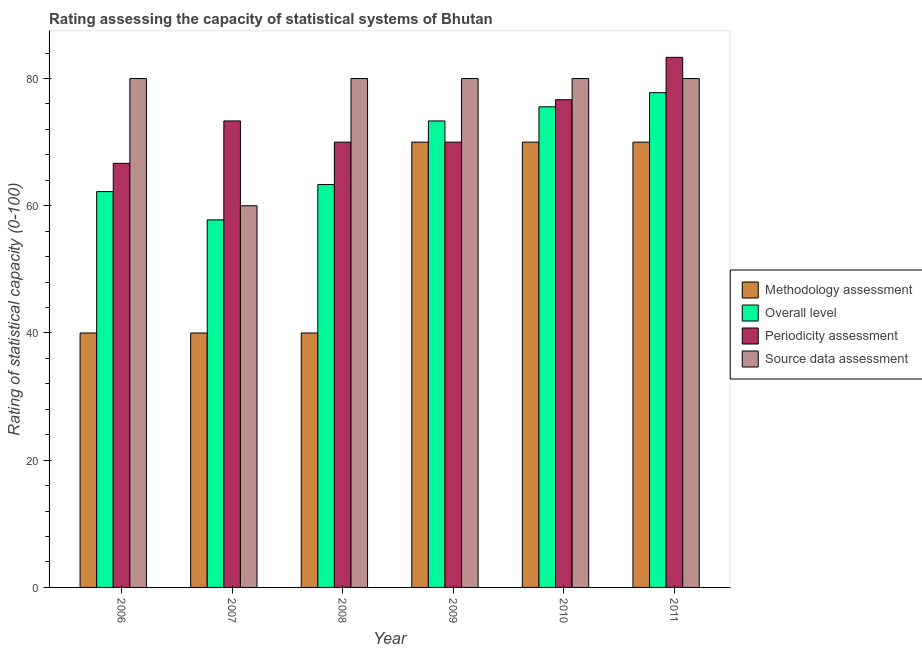How many different coloured bars are there?
Provide a short and direct response. 4. Are the number of bars per tick equal to the number of legend labels?
Provide a short and direct response. Yes. How many bars are there on the 5th tick from the left?
Provide a short and direct response. 4. What is the label of the 6th group of bars from the left?
Give a very brief answer. 2011. What is the methodology assessment rating in 2010?
Your answer should be very brief. 70. Across all years, what is the maximum source data assessment rating?
Your answer should be compact. 80. Across all years, what is the minimum periodicity assessment rating?
Offer a terse response. 66.67. In which year was the source data assessment rating maximum?
Give a very brief answer. 2006. What is the total methodology assessment rating in the graph?
Your answer should be compact. 330. What is the difference between the periodicity assessment rating in 2007 and that in 2008?
Keep it short and to the point. 3.33. What is the average periodicity assessment rating per year?
Make the answer very short. 73.33. What is the ratio of the source data assessment rating in 2006 to that in 2010?
Offer a terse response. 1. What is the difference between the highest and the second highest periodicity assessment rating?
Ensure brevity in your answer.  6.67. What is the difference between the highest and the lowest periodicity assessment rating?
Make the answer very short. 16.67. In how many years, is the overall level rating greater than the average overall level rating taken over all years?
Your response must be concise. 3. Is the sum of the periodicity assessment rating in 2007 and 2010 greater than the maximum overall level rating across all years?
Keep it short and to the point. Yes. What does the 3rd bar from the left in 2008 represents?
Offer a very short reply. Periodicity assessment. What does the 1st bar from the right in 2011 represents?
Provide a short and direct response. Source data assessment. How many bars are there?
Provide a succinct answer. 24. Are the values on the major ticks of Y-axis written in scientific E-notation?
Give a very brief answer. No. Does the graph contain any zero values?
Provide a short and direct response. No. Does the graph contain grids?
Your answer should be compact. No. Where does the legend appear in the graph?
Make the answer very short. Center right. How many legend labels are there?
Your answer should be very brief. 4. What is the title of the graph?
Your answer should be compact. Rating assessing the capacity of statistical systems of Bhutan. What is the label or title of the X-axis?
Your answer should be compact. Year. What is the label or title of the Y-axis?
Your response must be concise. Rating of statistical capacity (0-100). What is the Rating of statistical capacity (0-100) of Methodology assessment in 2006?
Your answer should be very brief. 40. What is the Rating of statistical capacity (0-100) in Overall level in 2006?
Offer a very short reply. 62.22. What is the Rating of statistical capacity (0-100) of Periodicity assessment in 2006?
Keep it short and to the point. 66.67. What is the Rating of statistical capacity (0-100) of Methodology assessment in 2007?
Provide a short and direct response. 40. What is the Rating of statistical capacity (0-100) in Overall level in 2007?
Offer a very short reply. 57.78. What is the Rating of statistical capacity (0-100) in Periodicity assessment in 2007?
Your response must be concise. 73.33. What is the Rating of statistical capacity (0-100) in Overall level in 2008?
Keep it short and to the point. 63.33. What is the Rating of statistical capacity (0-100) of Periodicity assessment in 2008?
Provide a short and direct response. 70. What is the Rating of statistical capacity (0-100) of Source data assessment in 2008?
Your answer should be very brief. 80. What is the Rating of statistical capacity (0-100) of Methodology assessment in 2009?
Make the answer very short. 70. What is the Rating of statistical capacity (0-100) in Overall level in 2009?
Your response must be concise. 73.33. What is the Rating of statistical capacity (0-100) in Periodicity assessment in 2009?
Make the answer very short. 70. What is the Rating of statistical capacity (0-100) in Methodology assessment in 2010?
Keep it short and to the point. 70. What is the Rating of statistical capacity (0-100) in Overall level in 2010?
Your answer should be compact. 75.56. What is the Rating of statistical capacity (0-100) in Periodicity assessment in 2010?
Keep it short and to the point. 76.67. What is the Rating of statistical capacity (0-100) in Overall level in 2011?
Make the answer very short. 77.78. What is the Rating of statistical capacity (0-100) of Periodicity assessment in 2011?
Your response must be concise. 83.33. What is the Rating of statistical capacity (0-100) in Source data assessment in 2011?
Your answer should be compact. 80. Across all years, what is the maximum Rating of statistical capacity (0-100) of Overall level?
Make the answer very short. 77.78. Across all years, what is the maximum Rating of statistical capacity (0-100) of Periodicity assessment?
Your answer should be compact. 83.33. Across all years, what is the maximum Rating of statistical capacity (0-100) of Source data assessment?
Keep it short and to the point. 80. Across all years, what is the minimum Rating of statistical capacity (0-100) in Overall level?
Your answer should be compact. 57.78. Across all years, what is the minimum Rating of statistical capacity (0-100) in Periodicity assessment?
Provide a succinct answer. 66.67. Across all years, what is the minimum Rating of statistical capacity (0-100) in Source data assessment?
Ensure brevity in your answer.  60. What is the total Rating of statistical capacity (0-100) in Methodology assessment in the graph?
Offer a terse response. 330. What is the total Rating of statistical capacity (0-100) in Overall level in the graph?
Offer a terse response. 410. What is the total Rating of statistical capacity (0-100) of Periodicity assessment in the graph?
Your answer should be very brief. 440. What is the total Rating of statistical capacity (0-100) in Source data assessment in the graph?
Provide a succinct answer. 460. What is the difference between the Rating of statistical capacity (0-100) of Overall level in 2006 and that in 2007?
Offer a terse response. 4.44. What is the difference between the Rating of statistical capacity (0-100) of Periodicity assessment in 2006 and that in 2007?
Offer a terse response. -6.67. What is the difference between the Rating of statistical capacity (0-100) of Source data assessment in 2006 and that in 2007?
Your response must be concise. 20. What is the difference between the Rating of statistical capacity (0-100) in Methodology assessment in 2006 and that in 2008?
Your answer should be compact. 0. What is the difference between the Rating of statistical capacity (0-100) in Overall level in 2006 and that in 2008?
Keep it short and to the point. -1.11. What is the difference between the Rating of statistical capacity (0-100) of Periodicity assessment in 2006 and that in 2008?
Offer a terse response. -3.33. What is the difference between the Rating of statistical capacity (0-100) of Overall level in 2006 and that in 2009?
Your answer should be very brief. -11.11. What is the difference between the Rating of statistical capacity (0-100) in Periodicity assessment in 2006 and that in 2009?
Ensure brevity in your answer.  -3.33. What is the difference between the Rating of statistical capacity (0-100) in Methodology assessment in 2006 and that in 2010?
Your answer should be very brief. -30. What is the difference between the Rating of statistical capacity (0-100) in Overall level in 2006 and that in 2010?
Provide a short and direct response. -13.33. What is the difference between the Rating of statistical capacity (0-100) in Periodicity assessment in 2006 and that in 2010?
Offer a terse response. -10. What is the difference between the Rating of statistical capacity (0-100) in Source data assessment in 2006 and that in 2010?
Keep it short and to the point. 0. What is the difference between the Rating of statistical capacity (0-100) in Overall level in 2006 and that in 2011?
Ensure brevity in your answer.  -15.56. What is the difference between the Rating of statistical capacity (0-100) in Periodicity assessment in 2006 and that in 2011?
Ensure brevity in your answer.  -16.67. What is the difference between the Rating of statistical capacity (0-100) of Source data assessment in 2006 and that in 2011?
Keep it short and to the point. 0. What is the difference between the Rating of statistical capacity (0-100) in Overall level in 2007 and that in 2008?
Ensure brevity in your answer.  -5.56. What is the difference between the Rating of statistical capacity (0-100) of Periodicity assessment in 2007 and that in 2008?
Provide a short and direct response. 3.33. What is the difference between the Rating of statistical capacity (0-100) in Source data assessment in 2007 and that in 2008?
Your answer should be compact. -20. What is the difference between the Rating of statistical capacity (0-100) in Methodology assessment in 2007 and that in 2009?
Provide a short and direct response. -30. What is the difference between the Rating of statistical capacity (0-100) in Overall level in 2007 and that in 2009?
Your response must be concise. -15.56. What is the difference between the Rating of statistical capacity (0-100) in Periodicity assessment in 2007 and that in 2009?
Provide a short and direct response. 3.33. What is the difference between the Rating of statistical capacity (0-100) in Source data assessment in 2007 and that in 2009?
Your answer should be compact. -20. What is the difference between the Rating of statistical capacity (0-100) of Overall level in 2007 and that in 2010?
Your answer should be compact. -17.78. What is the difference between the Rating of statistical capacity (0-100) in Source data assessment in 2007 and that in 2010?
Ensure brevity in your answer.  -20. What is the difference between the Rating of statistical capacity (0-100) of Methodology assessment in 2007 and that in 2011?
Your answer should be compact. -30. What is the difference between the Rating of statistical capacity (0-100) of Periodicity assessment in 2007 and that in 2011?
Provide a succinct answer. -10. What is the difference between the Rating of statistical capacity (0-100) of Overall level in 2008 and that in 2009?
Ensure brevity in your answer.  -10. What is the difference between the Rating of statistical capacity (0-100) of Periodicity assessment in 2008 and that in 2009?
Ensure brevity in your answer.  0. What is the difference between the Rating of statistical capacity (0-100) of Methodology assessment in 2008 and that in 2010?
Your answer should be compact. -30. What is the difference between the Rating of statistical capacity (0-100) of Overall level in 2008 and that in 2010?
Your answer should be compact. -12.22. What is the difference between the Rating of statistical capacity (0-100) of Periodicity assessment in 2008 and that in 2010?
Ensure brevity in your answer.  -6.67. What is the difference between the Rating of statistical capacity (0-100) of Source data assessment in 2008 and that in 2010?
Make the answer very short. 0. What is the difference between the Rating of statistical capacity (0-100) in Methodology assessment in 2008 and that in 2011?
Provide a short and direct response. -30. What is the difference between the Rating of statistical capacity (0-100) of Overall level in 2008 and that in 2011?
Offer a terse response. -14.44. What is the difference between the Rating of statistical capacity (0-100) of Periodicity assessment in 2008 and that in 2011?
Your answer should be very brief. -13.33. What is the difference between the Rating of statistical capacity (0-100) in Overall level in 2009 and that in 2010?
Make the answer very short. -2.22. What is the difference between the Rating of statistical capacity (0-100) in Periodicity assessment in 2009 and that in 2010?
Keep it short and to the point. -6.67. What is the difference between the Rating of statistical capacity (0-100) of Source data assessment in 2009 and that in 2010?
Make the answer very short. 0. What is the difference between the Rating of statistical capacity (0-100) of Methodology assessment in 2009 and that in 2011?
Offer a very short reply. 0. What is the difference between the Rating of statistical capacity (0-100) of Overall level in 2009 and that in 2011?
Give a very brief answer. -4.44. What is the difference between the Rating of statistical capacity (0-100) in Periodicity assessment in 2009 and that in 2011?
Keep it short and to the point. -13.33. What is the difference between the Rating of statistical capacity (0-100) of Source data assessment in 2009 and that in 2011?
Ensure brevity in your answer.  0. What is the difference between the Rating of statistical capacity (0-100) in Methodology assessment in 2010 and that in 2011?
Give a very brief answer. 0. What is the difference between the Rating of statistical capacity (0-100) of Overall level in 2010 and that in 2011?
Your answer should be compact. -2.22. What is the difference between the Rating of statistical capacity (0-100) in Periodicity assessment in 2010 and that in 2011?
Offer a very short reply. -6.67. What is the difference between the Rating of statistical capacity (0-100) in Source data assessment in 2010 and that in 2011?
Provide a short and direct response. 0. What is the difference between the Rating of statistical capacity (0-100) in Methodology assessment in 2006 and the Rating of statistical capacity (0-100) in Overall level in 2007?
Give a very brief answer. -17.78. What is the difference between the Rating of statistical capacity (0-100) of Methodology assessment in 2006 and the Rating of statistical capacity (0-100) of Periodicity assessment in 2007?
Offer a very short reply. -33.33. What is the difference between the Rating of statistical capacity (0-100) in Overall level in 2006 and the Rating of statistical capacity (0-100) in Periodicity assessment in 2007?
Provide a short and direct response. -11.11. What is the difference between the Rating of statistical capacity (0-100) in Overall level in 2006 and the Rating of statistical capacity (0-100) in Source data assessment in 2007?
Ensure brevity in your answer.  2.22. What is the difference between the Rating of statistical capacity (0-100) in Methodology assessment in 2006 and the Rating of statistical capacity (0-100) in Overall level in 2008?
Give a very brief answer. -23.33. What is the difference between the Rating of statistical capacity (0-100) in Overall level in 2006 and the Rating of statistical capacity (0-100) in Periodicity assessment in 2008?
Offer a very short reply. -7.78. What is the difference between the Rating of statistical capacity (0-100) in Overall level in 2006 and the Rating of statistical capacity (0-100) in Source data assessment in 2008?
Keep it short and to the point. -17.78. What is the difference between the Rating of statistical capacity (0-100) in Periodicity assessment in 2006 and the Rating of statistical capacity (0-100) in Source data assessment in 2008?
Ensure brevity in your answer.  -13.33. What is the difference between the Rating of statistical capacity (0-100) in Methodology assessment in 2006 and the Rating of statistical capacity (0-100) in Overall level in 2009?
Keep it short and to the point. -33.33. What is the difference between the Rating of statistical capacity (0-100) of Overall level in 2006 and the Rating of statistical capacity (0-100) of Periodicity assessment in 2009?
Keep it short and to the point. -7.78. What is the difference between the Rating of statistical capacity (0-100) in Overall level in 2006 and the Rating of statistical capacity (0-100) in Source data assessment in 2009?
Keep it short and to the point. -17.78. What is the difference between the Rating of statistical capacity (0-100) of Periodicity assessment in 2006 and the Rating of statistical capacity (0-100) of Source data assessment in 2009?
Your answer should be compact. -13.33. What is the difference between the Rating of statistical capacity (0-100) of Methodology assessment in 2006 and the Rating of statistical capacity (0-100) of Overall level in 2010?
Keep it short and to the point. -35.56. What is the difference between the Rating of statistical capacity (0-100) in Methodology assessment in 2006 and the Rating of statistical capacity (0-100) in Periodicity assessment in 2010?
Your response must be concise. -36.67. What is the difference between the Rating of statistical capacity (0-100) in Overall level in 2006 and the Rating of statistical capacity (0-100) in Periodicity assessment in 2010?
Keep it short and to the point. -14.44. What is the difference between the Rating of statistical capacity (0-100) in Overall level in 2006 and the Rating of statistical capacity (0-100) in Source data assessment in 2010?
Ensure brevity in your answer.  -17.78. What is the difference between the Rating of statistical capacity (0-100) of Periodicity assessment in 2006 and the Rating of statistical capacity (0-100) of Source data assessment in 2010?
Your answer should be compact. -13.33. What is the difference between the Rating of statistical capacity (0-100) of Methodology assessment in 2006 and the Rating of statistical capacity (0-100) of Overall level in 2011?
Your response must be concise. -37.78. What is the difference between the Rating of statistical capacity (0-100) of Methodology assessment in 2006 and the Rating of statistical capacity (0-100) of Periodicity assessment in 2011?
Offer a terse response. -43.33. What is the difference between the Rating of statistical capacity (0-100) in Methodology assessment in 2006 and the Rating of statistical capacity (0-100) in Source data assessment in 2011?
Make the answer very short. -40. What is the difference between the Rating of statistical capacity (0-100) in Overall level in 2006 and the Rating of statistical capacity (0-100) in Periodicity assessment in 2011?
Your response must be concise. -21.11. What is the difference between the Rating of statistical capacity (0-100) of Overall level in 2006 and the Rating of statistical capacity (0-100) of Source data assessment in 2011?
Your answer should be compact. -17.78. What is the difference between the Rating of statistical capacity (0-100) of Periodicity assessment in 2006 and the Rating of statistical capacity (0-100) of Source data assessment in 2011?
Provide a succinct answer. -13.33. What is the difference between the Rating of statistical capacity (0-100) of Methodology assessment in 2007 and the Rating of statistical capacity (0-100) of Overall level in 2008?
Your answer should be compact. -23.33. What is the difference between the Rating of statistical capacity (0-100) in Methodology assessment in 2007 and the Rating of statistical capacity (0-100) in Periodicity assessment in 2008?
Provide a succinct answer. -30. What is the difference between the Rating of statistical capacity (0-100) in Methodology assessment in 2007 and the Rating of statistical capacity (0-100) in Source data assessment in 2008?
Keep it short and to the point. -40. What is the difference between the Rating of statistical capacity (0-100) of Overall level in 2007 and the Rating of statistical capacity (0-100) of Periodicity assessment in 2008?
Provide a succinct answer. -12.22. What is the difference between the Rating of statistical capacity (0-100) in Overall level in 2007 and the Rating of statistical capacity (0-100) in Source data assessment in 2008?
Offer a terse response. -22.22. What is the difference between the Rating of statistical capacity (0-100) of Periodicity assessment in 2007 and the Rating of statistical capacity (0-100) of Source data assessment in 2008?
Ensure brevity in your answer.  -6.67. What is the difference between the Rating of statistical capacity (0-100) of Methodology assessment in 2007 and the Rating of statistical capacity (0-100) of Overall level in 2009?
Ensure brevity in your answer.  -33.33. What is the difference between the Rating of statistical capacity (0-100) of Methodology assessment in 2007 and the Rating of statistical capacity (0-100) of Periodicity assessment in 2009?
Make the answer very short. -30. What is the difference between the Rating of statistical capacity (0-100) of Methodology assessment in 2007 and the Rating of statistical capacity (0-100) of Source data assessment in 2009?
Your response must be concise. -40. What is the difference between the Rating of statistical capacity (0-100) of Overall level in 2007 and the Rating of statistical capacity (0-100) of Periodicity assessment in 2009?
Provide a succinct answer. -12.22. What is the difference between the Rating of statistical capacity (0-100) in Overall level in 2007 and the Rating of statistical capacity (0-100) in Source data assessment in 2009?
Provide a short and direct response. -22.22. What is the difference between the Rating of statistical capacity (0-100) of Periodicity assessment in 2007 and the Rating of statistical capacity (0-100) of Source data assessment in 2009?
Your answer should be very brief. -6.67. What is the difference between the Rating of statistical capacity (0-100) in Methodology assessment in 2007 and the Rating of statistical capacity (0-100) in Overall level in 2010?
Your response must be concise. -35.56. What is the difference between the Rating of statistical capacity (0-100) of Methodology assessment in 2007 and the Rating of statistical capacity (0-100) of Periodicity assessment in 2010?
Ensure brevity in your answer.  -36.67. What is the difference between the Rating of statistical capacity (0-100) of Overall level in 2007 and the Rating of statistical capacity (0-100) of Periodicity assessment in 2010?
Ensure brevity in your answer.  -18.89. What is the difference between the Rating of statistical capacity (0-100) in Overall level in 2007 and the Rating of statistical capacity (0-100) in Source data assessment in 2010?
Make the answer very short. -22.22. What is the difference between the Rating of statistical capacity (0-100) of Periodicity assessment in 2007 and the Rating of statistical capacity (0-100) of Source data assessment in 2010?
Keep it short and to the point. -6.67. What is the difference between the Rating of statistical capacity (0-100) of Methodology assessment in 2007 and the Rating of statistical capacity (0-100) of Overall level in 2011?
Your answer should be compact. -37.78. What is the difference between the Rating of statistical capacity (0-100) of Methodology assessment in 2007 and the Rating of statistical capacity (0-100) of Periodicity assessment in 2011?
Provide a short and direct response. -43.33. What is the difference between the Rating of statistical capacity (0-100) in Overall level in 2007 and the Rating of statistical capacity (0-100) in Periodicity assessment in 2011?
Make the answer very short. -25.56. What is the difference between the Rating of statistical capacity (0-100) of Overall level in 2007 and the Rating of statistical capacity (0-100) of Source data assessment in 2011?
Provide a short and direct response. -22.22. What is the difference between the Rating of statistical capacity (0-100) in Periodicity assessment in 2007 and the Rating of statistical capacity (0-100) in Source data assessment in 2011?
Provide a short and direct response. -6.67. What is the difference between the Rating of statistical capacity (0-100) in Methodology assessment in 2008 and the Rating of statistical capacity (0-100) in Overall level in 2009?
Offer a terse response. -33.33. What is the difference between the Rating of statistical capacity (0-100) in Methodology assessment in 2008 and the Rating of statistical capacity (0-100) in Periodicity assessment in 2009?
Offer a very short reply. -30. What is the difference between the Rating of statistical capacity (0-100) in Overall level in 2008 and the Rating of statistical capacity (0-100) in Periodicity assessment in 2009?
Make the answer very short. -6.67. What is the difference between the Rating of statistical capacity (0-100) in Overall level in 2008 and the Rating of statistical capacity (0-100) in Source data assessment in 2009?
Give a very brief answer. -16.67. What is the difference between the Rating of statistical capacity (0-100) in Methodology assessment in 2008 and the Rating of statistical capacity (0-100) in Overall level in 2010?
Give a very brief answer. -35.56. What is the difference between the Rating of statistical capacity (0-100) of Methodology assessment in 2008 and the Rating of statistical capacity (0-100) of Periodicity assessment in 2010?
Offer a very short reply. -36.67. What is the difference between the Rating of statistical capacity (0-100) in Overall level in 2008 and the Rating of statistical capacity (0-100) in Periodicity assessment in 2010?
Ensure brevity in your answer.  -13.33. What is the difference between the Rating of statistical capacity (0-100) in Overall level in 2008 and the Rating of statistical capacity (0-100) in Source data assessment in 2010?
Provide a succinct answer. -16.67. What is the difference between the Rating of statistical capacity (0-100) in Methodology assessment in 2008 and the Rating of statistical capacity (0-100) in Overall level in 2011?
Offer a very short reply. -37.78. What is the difference between the Rating of statistical capacity (0-100) in Methodology assessment in 2008 and the Rating of statistical capacity (0-100) in Periodicity assessment in 2011?
Offer a terse response. -43.33. What is the difference between the Rating of statistical capacity (0-100) in Methodology assessment in 2008 and the Rating of statistical capacity (0-100) in Source data assessment in 2011?
Offer a terse response. -40. What is the difference between the Rating of statistical capacity (0-100) in Overall level in 2008 and the Rating of statistical capacity (0-100) in Periodicity assessment in 2011?
Offer a terse response. -20. What is the difference between the Rating of statistical capacity (0-100) in Overall level in 2008 and the Rating of statistical capacity (0-100) in Source data assessment in 2011?
Provide a short and direct response. -16.67. What is the difference between the Rating of statistical capacity (0-100) of Methodology assessment in 2009 and the Rating of statistical capacity (0-100) of Overall level in 2010?
Ensure brevity in your answer.  -5.56. What is the difference between the Rating of statistical capacity (0-100) in Methodology assessment in 2009 and the Rating of statistical capacity (0-100) in Periodicity assessment in 2010?
Give a very brief answer. -6.67. What is the difference between the Rating of statistical capacity (0-100) in Methodology assessment in 2009 and the Rating of statistical capacity (0-100) in Source data assessment in 2010?
Offer a very short reply. -10. What is the difference between the Rating of statistical capacity (0-100) of Overall level in 2009 and the Rating of statistical capacity (0-100) of Periodicity assessment in 2010?
Offer a terse response. -3.33. What is the difference between the Rating of statistical capacity (0-100) of Overall level in 2009 and the Rating of statistical capacity (0-100) of Source data assessment in 2010?
Offer a very short reply. -6.67. What is the difference between the Rating of statistical capacity (0-100) in Periodicity assessment in 2009 and the Rating of statistical capacity (0-100) in Source data assessment in 2010?
Keep it short and to the point. -10. What is the difference between the Rating of statistical capacity (0-100) in Methodology assessment in 2009 and the Rating of statistical capacity (0-100) in Overall level in 2011?
Make the answer very short. -7.78. What is the difference between the Rating of statistical capacity (0-100) in Methodology assessment in 2009 and the Rating of statistical capacity (0-100) in Periodicity assessment in 2011?
Make the answer very short. -13.33. What is the difference between the Rating of statistical capacity (0-100) in Methodology assessment in 2009 and the Rating of statistical capacity (0-100) in Source data assessment in 2011?
Your answer should be very brief. -10. What is the difference between the Rating of statistical capacity (0-100) of Overall level in 2009 and the Rating of statistical capacity (0-100) of Source data assessment in 2011?
Give a very brief answer. -6.67. What is the difference between the Rating of statistical capacity (0-100) in Periodicity assessment in 2009 and the Rating of statistical capacity (0-100) in Source data assessment in 2011?
Your response must be concise. -10. What is the difference between the Rating of statistical capacity (0-100) in Methodology assessment in 2010 and the Rating of statistical capacity (0-100) in Overall level in 2011?
Keep it short and to the point. -7.78. What is the difference between the Rating of statistical capacity (0-100) of Methodology assessment in 2010 and the Rating of statistical capacity (0-100) of Periodicity assessment in 2011?
Ensure brevity in your answer.  -13.33. What is the difference between the Rating of statistical capacity (0-100) in Methodology assessment in 2010 and the Rating of statistical capacity (0-100) in Source data assessment in 2011?
Ensure brevity in your answer.  -10. What is the difference between the Rating of statistical capacity (0-100) in Overall level in 2010 and the Rating of statistical capacity (0-100) in Periodicity assessment in 2011?
Provide a short and direct response. -7.78. What is the difference between the Rating of statistical capacity (0-100) of Overall level in 2010 and the Rating of statistical capacity (0-100) of Source data assessment in 2011?
Your response must be concise. -4.44. What is the average Rating of statistical capacity (0-100) in Methodology assessment per year?
Give a very brief answer. 55. What is the average Rating of statistical capacity (0-100) of Overall level per year?
Offer a very short reply. 68.33. What is the average Rating of statistical capacity (0-100) in Periodicity assessment per year?
Your answer should be compact. 73.33. What is the average Rating of statistical capacity (0-100) of Source data assessment per year?
Offer a very short reply. 76.67. In the year 2006, what is the difference between the Rating of statistical capacity (0-100) of Methodology assessment and Rating of statistical capacity (0-100) of Overall level?
Offer a terse response. -22.22. In the year 2006, what is the difference between the Rating of statistical capacity (0-100) of Methodology assessment and Rating of statistical capacity (0-100) of Periodicity assessment?
Ensure brevity in your answer.  -26.67. In the year 2006, what is the difference between the Rating of statistical capacity (0-100) in Methodology assessment and Rating of statistical capacity (0-100) in Source data assessment?
Your answer should be very brief. -40. In the year 2006, what is the difference between the Rating of statistical capacity (0-100) of Overall level and Rating of statistical capacity (0-100) of Periodicity assessment?
Make the answer very short. -4.44. In the year 2006, what is the difference between the Rating of statistical capacity (0-100) of Overall level and Rating of statistical capacity (0-100) of Source data assessment?
Offer a very short reply. -17.78. In the year 2006, what is the difference between the Rating of statistical capacity (0-100) in Periodicity assessment and Rating of statistical capacity (0-100) in Source data assessment?
Make the answer very short. -13.33. In the year 2007, what is the difference between the Rating of statistical capacity (0-100) of Methodology assessment and Rating of statistical capacity (0-100) of Overall level?
Your answer should be compact. -17.78. In the year 2007, what is the difference between the Rating of statistical capacity (0-100) in Methodology assessment and Rating of statistical capacity (0-100) in Periodicity assessment?
Offer a terse response. -33.33. In the year 2007, what is the difference between the Rating of statistical capacity (0-100) of Overall level and Rating of statistical capacity (0-100) of Periodicity assessment?
Give a very brief answer. -15.56. In the year 2007, what is the difference between the Rating of statistical capacity (0-100) in Overall level and Rating of statistical capacity (0-100) in Source data assessment?
Give a very brief answer. -2.22. In the year 2007, what is the difference between the Rating of statistical capacity (0-100) in Periodicity assessment and Rating of statistical capacity (0-100) in Source data assessment?
Your answer should be very brief. 13.33. In the year 2008, what is the difference between the Rating of statistical capacity (0-100) of Methodology assessment and Rating of statistical capacity (0-100) of Overall level?
Keep it short and to the point. -23.33. In the year 2008, what is the difference between the Rating of statistical capacity (0-100) in Methodology assessment and Rating of statistical capacity (0-100) in Source data assessment?
Ensure brevity in your answer.  -40. In the year 2008, what is the difference between the Rating of statistical capacity (0-100) in Overall level and Rating of statistical capacity (0-100) in Periodicity assessment?
Offer a terse response. -6.67. In the year 2008, what is the difference between the Rating of statistical capacity (0-100) in Overall level and Rating of statistical capacity (0-100) in Source data assessment?
Ensure brevity in your answer.  -16.67. In the year 2009, what is the difference between the Rating of statistical capacity (0-100) of Methodology assessment and Rating of statistical capacity (0-100) of Periodicity assessment?
Your response must be concise. 0. In the year 2009, what is the difference between the Rating of statistical capacity (0-100) in Overall level and Rating of statistical capacity (0-100) in Periodicity assessment?
Your answer should be compact. 3.33. In the year 2009, what is the difference between the Rating of statistical capacity (0-100) in Overall level and Rating of statistical capacity (0-100) in Source data assessment?
Your answer should be very brief. -6.67. In the year 2010, what is the difference between the Rating of statistical capacity (0-100) of Methodology assessment and Rating of statistical capacity (0-100) of Overall level?
Give a very brief answer. -5.56. In the year 2010, what is the difference between the Rating of statistical capacity (0-100) of Methodology assessment and Rating of statistical capacity (0-100) of Periodicity assessment?
Give a very brief answer. -6.67. In the year 2010, what is the difference between the Rating of statistical capacity (0-100) of Overall level and Rating of statistical capacity (0-100) of Periodicity assessment?
Offer a very short reply. -1.11. In the year 2010, what is the difference between the Rating of statistical capacity (0-100) of Overall level and Rating of statistical capacity (0-100) of Source data assessment?
Your response must be concise. -4.44. In the year 2010, what is the difference between the Rating of statistical capacity (0-100) in Periodicity assessment and Rating of statistical capacity (0-100) in Source data assessment?
Make the answer very short. -3.33. In the year 2011, what is the difference between the Rating of statistical capacity (0-100) of Methodology assessment and Rating of statistical capacity (0-100) of Overall level?
Offer a terse response. -7.78. In the year 2011, what is the difference between the Rating of statistical capacity (0-100) in Methodology assessment and Rating of statistical capacity (0-100) in Periodicity assessment?
Your response must be concise. -13.33. In the year 2011, what is the difference between the Rating of statistical capacity (0-100) of Overall level and Rating of statistical capacity (0-100) of Periodicity assessment?
Offer a very short reply. -5.56. In the year 2011, what is the difference between the Rating of statistical capacity (0-100) of Overall level and Rating of statistical capacity (0-100) of Source data assessment?
Offer a very short reply. -2.22. In the year 2011, what is the difference between the Rating of statistical capacity (0-100) in Periodicity assessment and Rating of statistical capacity (0-100) in Source data assessment?
Your answer should be compact. 3.33. What is the ratio of the Rating of statistical capacity (0-100) of Periodicity assessment in 2006 to that in 2007?
Your response must be concise. 0.91. What is the ratio of the Rating of statistical capacity (0-100) in Source data assessment in 2006 to that in 2007?
Offer a very short reply. 1.33. What is the ratio of the Rating of statistical capacity (0-100) in Methodology assessment in 2006 to that in 2008?
Make the answer very short. 1. What is the ratio of the Rating of statistical capacity (0-100) of Overall level in 2006 to that in 2008?
Provide a succinct answer. 0.98. What is the ratio of the Rating of statistical capacity (0-100) in Periodicity assessment in 2006 to that in 2008?
Provide a succinct answer. 0.95. What is the ratio of the Rating of statistical capacity (0-100) of Source data assessment in 2006 to that in 2008?
Your response must be concise. 1. What is the ratio of the Rating of statistical capacity (0-100) of Methodology assessment in 2006 to that in 2009?
Your answer should be compact. 0.57. What is the ratio of the Rating of statistical capacity (0-100) of Overall level in 2006 to that in 2009?
Provide a succinct answer. 0.85. What is the ratio of the Rating of statistical capacity (0-100) in Periodicity assessment in 2006 to that in 2009?
Your response must be concise. 0.95. What is the ratio of the Rating of statistical capacity (0-100) in Source data assessment in 2006 to that in 2009?
Provide a short and direct response. 1. What is the ratio of the Rating of statistical capacity (0-100) of Methodology assessment in 2006 to that in 2010?
Give a very brief answer. 0.57. What is the ratio of the Rating of statistical capacity (0-100) of Overall level in 2006 to that in 2010?
Offer a terse response. 0.82. What is the ratio of the Rating of statistical capacity (0-100) of Periodicity assessment in 2006 to that in 2010?
Provide a succinct answer. 0.87. What is the ratio of the Rating of statistical capacity (0-100) in Source data assessment in 2006 to that in 2010?
Your response must be concise. 1. What is the ratio of the Rating of statistical capacity (0-100) of Source data assessment in 2006 to that in 2011?
Provide a short and direct response. 1. What is the ratio of the Rating of statistical capacity (0-100) of Overall level in 2007 to that in 2008?
Give a very brief answer. 0.91. What is the ratio of the Rating of statistical capacity (0-100) of Periodicity assessment in 2007 to that in 2008?
Your answer should be very brief. 1.05. What is the ratio of the Rating of statistical capacity (0-100) of Source data assessment in 2007 to that in 2008?
Offer a terse response. 0.75. What is the ratio of the Rating of statistical capacity (0-100) in Methodology assessment in 2007 to that in 2009?
Ensure brevity in your answer.  0.57. What is the ratio of the Rating of statistical capacity (0-100) in Overall level in 2007 to that in 2009?
Provide a succinct answer. 0.79. What is the ratio of the Rating of statistical capacity (0-100) in Periodicity assessment in 2007 to that in 2009?
Make the answer very short. 1.05. What is the ratio of the Rating of statistical capacity (0-100) in Overall level in 2007 to that in 2010?
Your answer should be compact. 0.76. What is the ratio of the Rating of statistical capacity (0-100) of Periodicity assessment in 2007 to that in 2010?
Make the answer very short. 0.96. What is the ratio of the Rating of statistical capacity (0-100) in Source data assessment in 2007 to that in 2010?
Give a very brief answer. 0.75. What is the ratio of the Rating of statistical capacity (0-100) in Overall level in 2007 to that in 2011?
Offer a very short reply. 0.74. What is the ratio of the Rating of statistical capacity (0-100) in Periodicity assessment in 2007 to that in 2011?
Your response must be concise. 0.88. What is the ratio of the Rating of statistical capacity (0-100) in Source data assessment in 2007 to that in 2011?
Offer a terse response. 0.75. What is the ratio of the Rating of statistical capacity (0-100) in Methodology assessment in 2008 to that in 2009?
Provide a short and direct response. 0.57. What is the ratio of the Rating of statistical capacity (0-100) of Overall level in 2008 to that in 2009?
Your answer should be compact. 0.86. What is the ratio of the Rating of statistical capacity (0-100) of Periodicity assessment in 2008 to that in 2009?
Ensure brevity in your answer.  1. What is the ratio of the Rating of statistical capacity (0-100) in Source data assessment in 2008 to that in 2009?
Your answer should be very brief. 1. What is the ratio of the Rating of statistical capacity (0-100) in Methodology assessment in 2008 to that in 2010?
Make the answer very short. 0.57. What is the ratio of the Rating of statistical capacity (0-100) of Overall level in 2008 to that in 2010?
Offer a terse response. 0.84. What is the ratio of the Rating of statistical capacity (0-100) of Periodicity assessment in 2008 to that in 2010?
Make the answer very short. 0.91. What is the ratio of the Rating of statistical capacity (0-100) of Overall level in 2008 to that in 2011?
Your answer should be very brief. 0.81. What is the ratio of the Rating of statistical capacity (0-100) of Periodicity assessment in 2008 to that in 2011?
Keep it short and to the point. 0.84. What is the ratio of the Rating of statistical capacity (0-100) in Source data assessment in 2008 to that in 2011?
Keep it short and to the point. 1. What is the ratio of the Rating of statistical capacity (0-100) of Methodology assessment in 2009 to that in 2010?
Provide a succinct answer. 1. What is the ratio of the Rating of statistical capacity (0-100) of Overall level in 2009 to that in 2010?
Give a very brief answer. 0.97. What is the ratio of the Rating of statistical capacity (0-100) of Methodology assessment in 2009 to that in 2011?
Provide a short and direct response. 1. What is the ratio of the Rating of statistical capacity (0-100) in Overall level in 2009 to that in 2011?
Ensure brevity in your answer.  0.94. What is the ratio of the Rating of statistical capacity (0-100) of Periodicity assessment in 2009 to that in 2011?
Keep it short and to the point. 0.84. What is the ratio of the Rating of statistical capacity (0-100) in Source data assessment in 2009 to that in 2011?
Your answer should be compact. 1. What is the ratio of the Rating of statistical capacity (0-100) in Methodology assessment in 2010 to that in 2011?
Make the answer very short. 1. What is the ratio of the Rating of statistical capacity (0-100) of Overall level in 2010 to that in 2011?
Offer a very short reply. 0.97. What is the ratio of the Rating of statistical capacity (0-100) of Periodicity assessment in 2010 to that in 2011?
Give a very brief answer. 0.92. What is the ratio of the Rating of statistical capacity (0-100) in Source data assessment in 2010 to that in 2011?
Your answer should be very brief. 1. What is the difference between the highest and the second highest Rating of statistical capacity (0-100) in Overall level?
Your answer should be compact. 2.22. What is the difference between the highest and the second highest Rating of statistical capacity (0-100) of Source data assessment?
Provide a succinct answer. 0. What is the difference between the highest and the lowest Rating of statistical capacity (0-100) of Methodology assessment?
Make the answer very short. 30. What is the difference between the highest and the lowest Rating of statistical capacity (0-100) of Periodicity assessment?
Offer a terse response. 16.67. What is the difference between the highest and the lowest Rating of statistical capacity (0-100) in Source data assessment?
Offer a terse response. 20. 